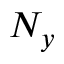Convert formula to latex. <formula><loc_0><loc_0><loc_500><loc_500>N _ { y }</formula> 